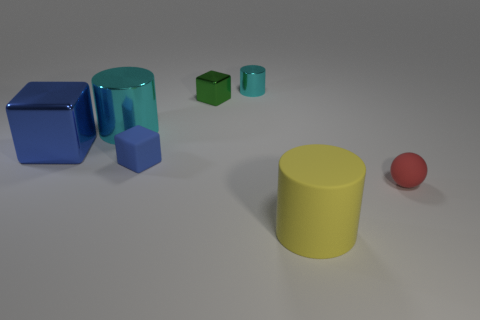Subtract all small cylinders. How many cylinders are left? 2 Subtract all green cubes. How many cubes are left? 2 Add 2 blue rubber cubes. How many objects exist? 9 Subtract all blue cylinders. How many blue blocks are left? 2 Subtract all blocks. How many objects are left? 4 Subtract 0 gray balls. How many objects are left? 7 Subtract 2 cylinders. How many cylinders are left? 1 Subtract all yellow blocks. Subtract all gray cylinders. How many blocks are left? 3 Subtract all blue things. Subtract all red spheres. How many objects are left? 4 Add 6 tiny blocks. How many tiny blocks are left? 8 